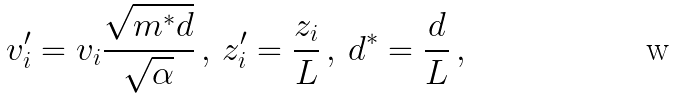Convert formula to latex. <formula><loc_0><loc_0><loc_500><loc_500>v _ { i } ^ { \prime } = v _ { i } \frac { \sqrt { m ^ { * } d } } { \sqrt { \alpha } } \, , \, z _ { i } ^ { \prime } = \frac { z _ { i } } { L } \, , \, d ^ { * } = \frac { d } { L } \, ,</formula> 